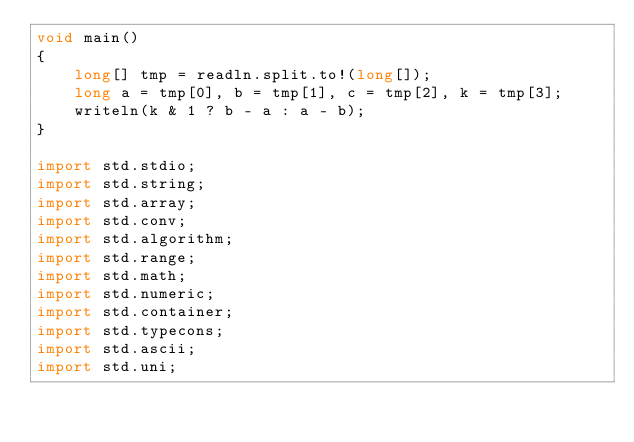<code> <loc_0><loc_0><loc_500><loc_500><_D_>void main()
{
    long[] tmp = readln.split.to!(long[]);
    long a = tmp[0], b = tmp[1], c = tmp[2], k = tmp[3];
    writeln(k & 1 ? b - a : a - b);
}

import std.stdio;
import std.string;
import std.array;
import std.conv;
import std.algorithm;
import std.range;
import std.math;
import std.numeric;
import std.container;
import std.typecons;
import std.ascii;
import std.uni;</code> 